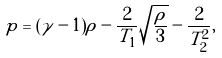Convert formula to latex. <formula><loc_0><loc_0><loc_500><loc_500>p = ( \tilde { \gamma } - 1 ) \rho - \frac { 2 } { T _ { 1 } } \sqrt { \frac { \rho } { 3 } } - \frac { 2 } { T ^ { 2 } _ { 2 } } ,</formula> 